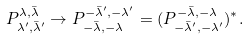<formula> <loc_0><loc_0><loc_500><loc_500>P ^ { \lambda , \bar { \lambda } } _ { \lambda ^ { \prime } , \bar { \lambda } ^ { \prime } } \to P ^ { - \bar { \lambda } ^ { \prime } , - \lambda ^ { \prime } } _ { - \bar { \lambda } , - \lambda } = ( P ^ { - \bar { \lambda } , - \lambda } _ { - \bar { \lambda } ^ { \prime } , - \lambda ^ { \prime } } ) ^ { * } .</formula> 